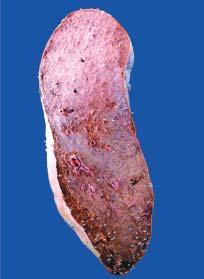what is the colour of sectioned surface?
Answer the question using a single word or phrase. Grey-tan 